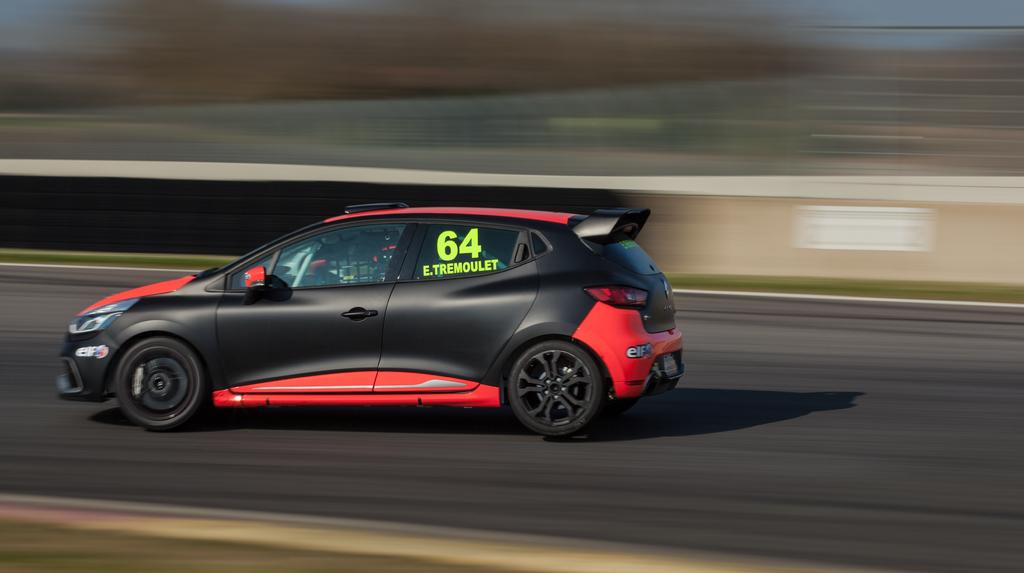What color is the car in the image? The car in the image is black and red. What is the car doing in the image? The car is moving on a road track. Can you describe the background of the image? The background of the image is blurred. How many seeds are scattered on the road track in the image? There are no seeds present in the image; it features a black and red car moving on a road track with a blurred background. 